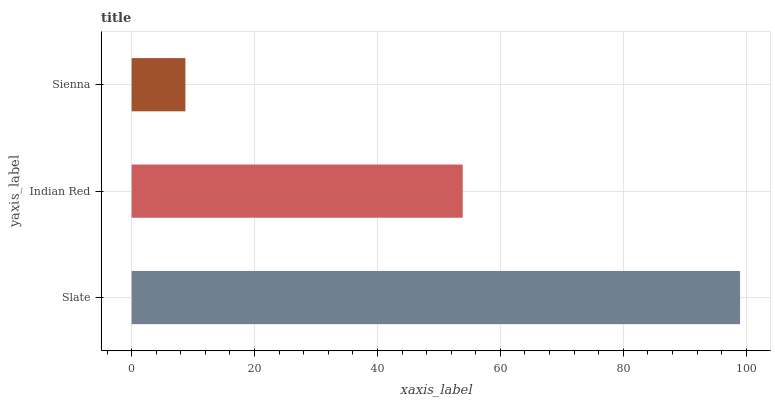Is Sienna the minimum?
Answer yes or no. Yes. Is Slate the maximum?
Answer yes or no. Yes. Is Indian Red the minimum?
Answer yes or no. No. Is Indian Red the maximum?
Answer yes or no. No. Is Slate greater than Indian Red?
Answer yes or no. Yes. Is Indian Red less than Slate?
Answer yes or no. Yes. Is Indian Red greater than Slate?
Answer yes or no. No. Is Slate less than Indian Red?
Answer yes or no. No. Is Indian Red the high median?
Answer yes or no. Yes. Is Indian Red the low median?
Answer yes or no. Yes. Is Sienna the high median?
Answer yes or no. No. Is Sienna the low median?
Answer yes or no. No. 